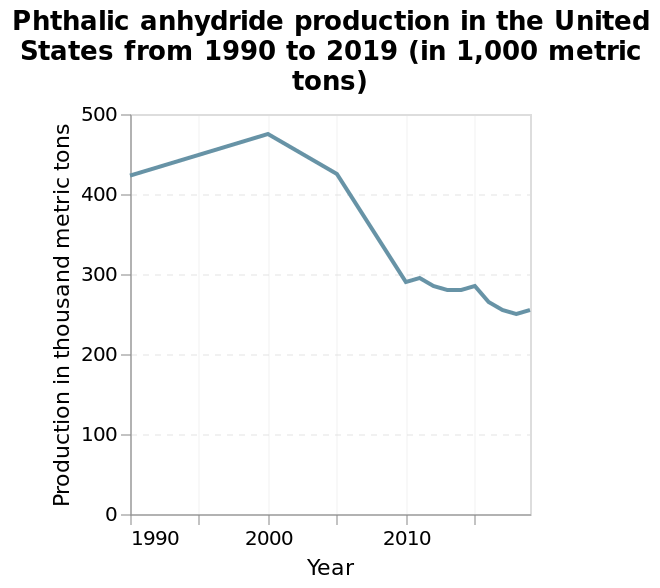<image>
Has there been any recent increase in Phthalic anhydride production? Yes, there has been a slight increase in Phthalic anhydride production from 2018 to 2020. 